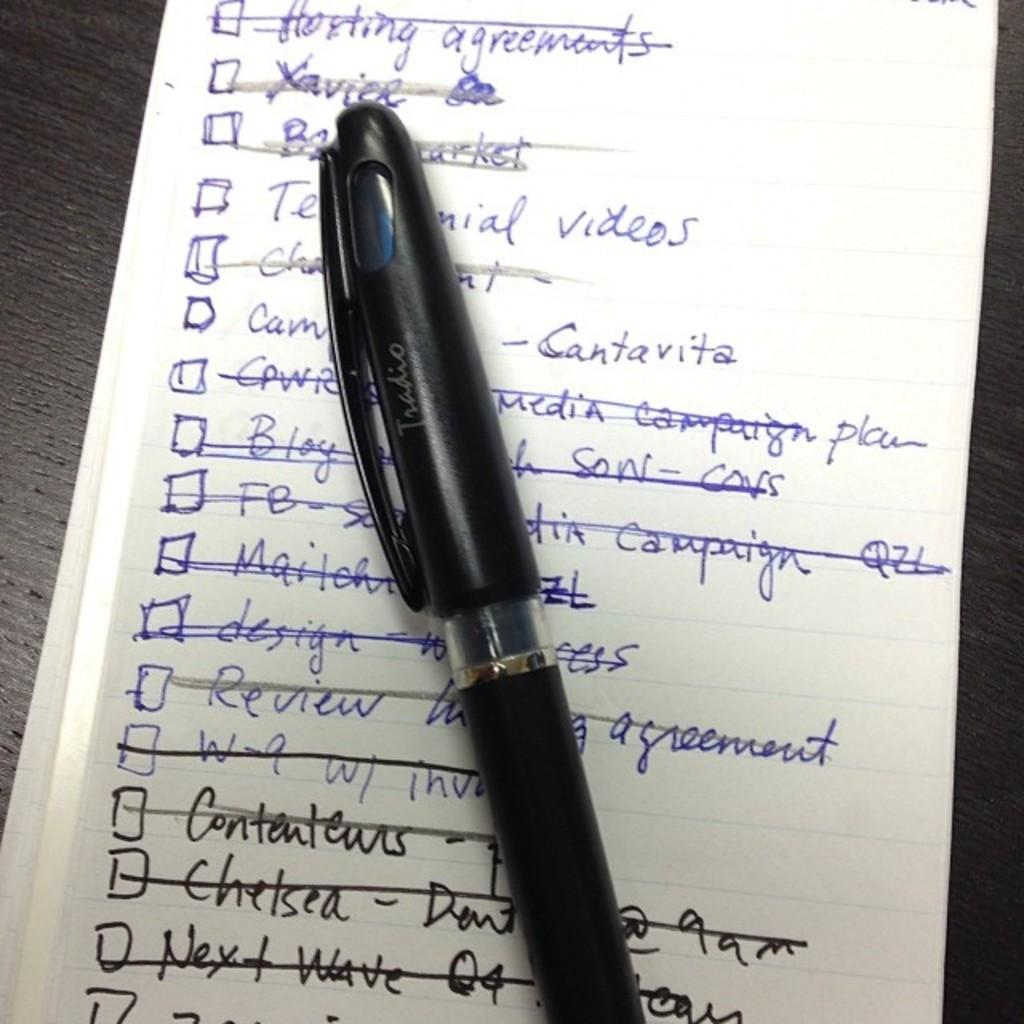What object is placed on the paper in the image? There is a pen on a paper in the image. What can be seen on the paper besides the pen? There is text on the paper. What type of surface is visible on the right side of the image? There is a wooden surface on the right side of the image. What type of surface is visible on the left side of the image? There is a wooden surface on the left side of the image. What type of twig is being used for teaching in the image? There is no twig present in the image, nor is there any teaching activity depicted. 